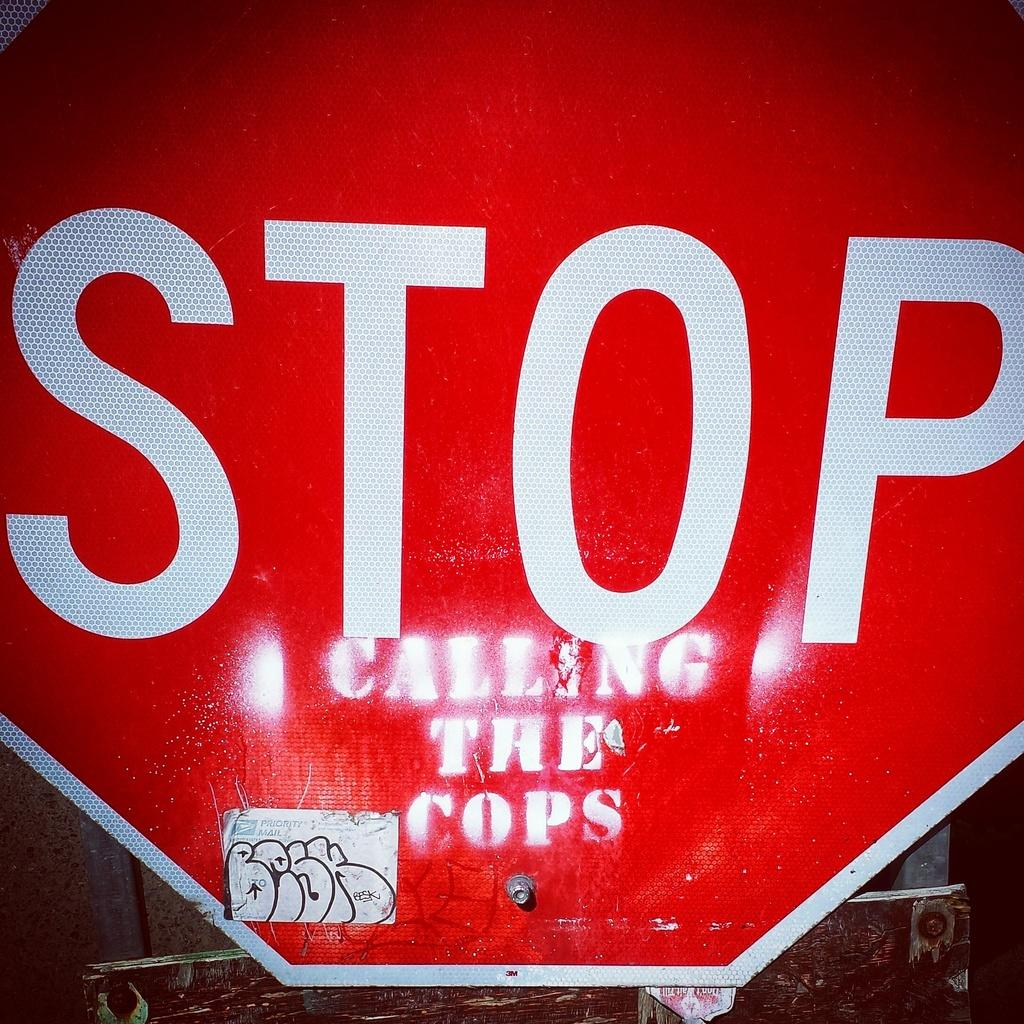<image>
Give a short and clear explanation of the subsequent image. A large red stop sign has graffiti on it that says calling the cops. 